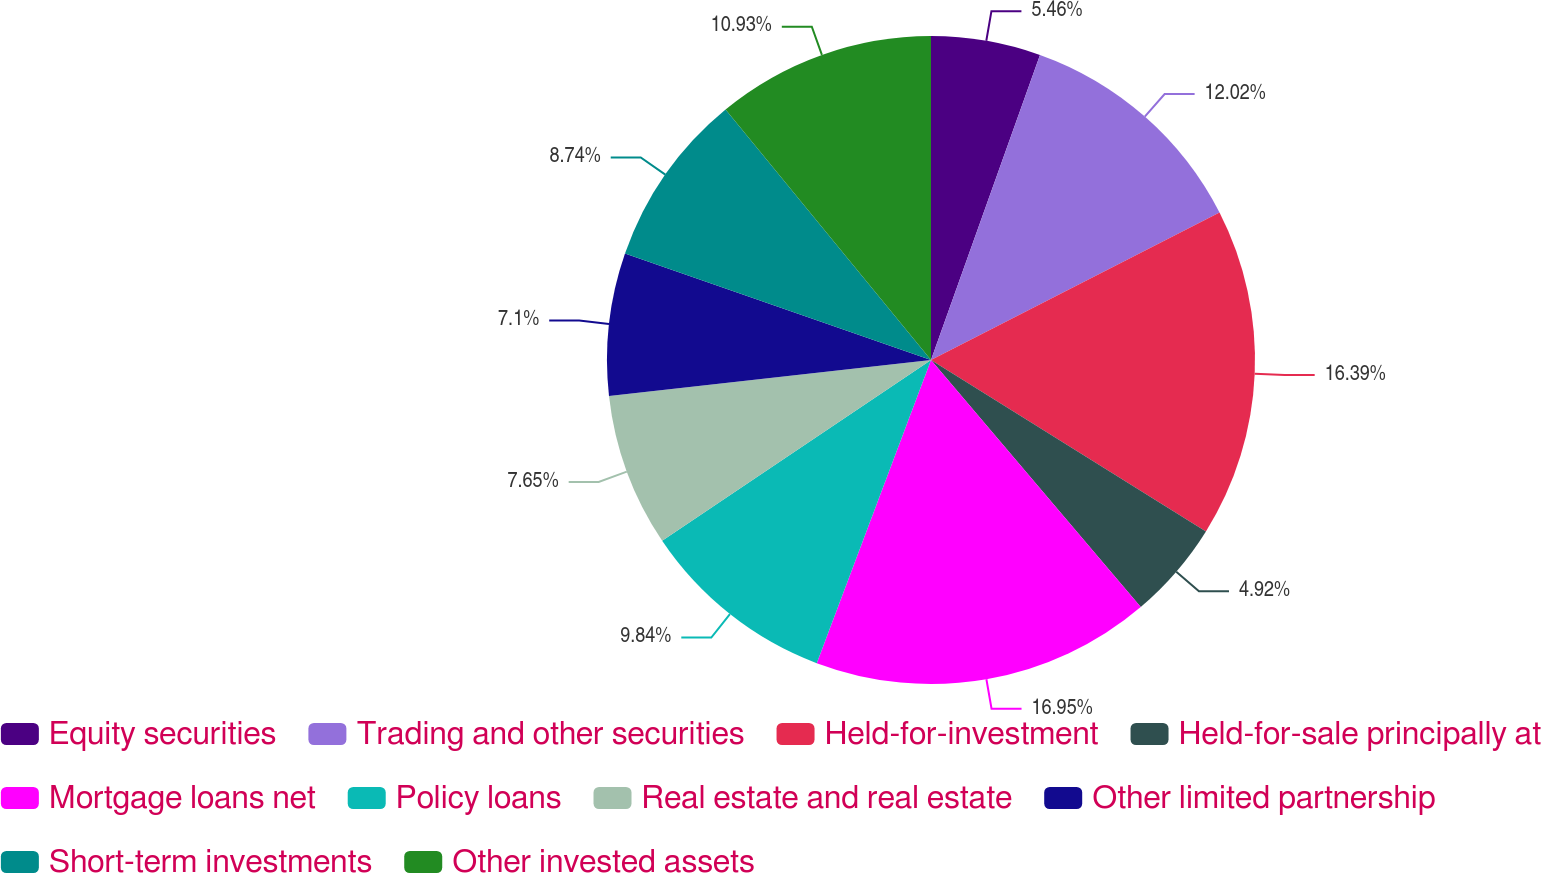<chart> <loc_0><loc_0><loc_500><loc_500><pie_chart><fcel>Equity securities<fcel>Trading and other securities<fcel>Held-for-investment<fcel>Held-for-sale principally at<fcel>Mortgage loans net<fcel>Policy loans<fcel>Real estate and real estate<fcel>Other limited partnership<fcel>Short-term investments<fcel>Other invested assets<nl><fcel>5.46%<fcel>12.02%<fcel>16.39%<fcel>4.92%<fcel>16.94%<fcel>9.84%<fcel>7.65%<fcel>7.1%<fcel>8.74%<fcel>10.93%<nl></chart> 